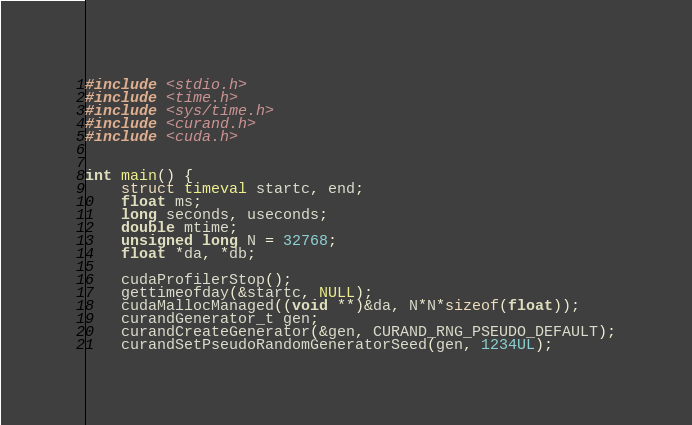Convert code to text. <code><loc_0><loc_0><loc_500><loc_500><_Cuda_>#include <stdio.h>
#include <time.h>
#include <sys/time.h>
#include <curand.h>
#include <cuda.h>


int main() {
    struct timeval startc, end;
    float ms;
    long seconds, useconds;
    double mtime;
    unsigned long N = 32768;
    float *da, *db;

    cudaProfilerStop();
    gettimeofday(&startc, NULL);
    cudaMallocManaged((void **)&da, N*N*sizeof(float));
    curandGenerator_t gen;
    curandCreateGenerator(&gen, CURAND_RNG_PSEUDO_DEFAULT);
    curandSetPseudoRandomGeneratorSeed(gen, 1234UL);</code> 